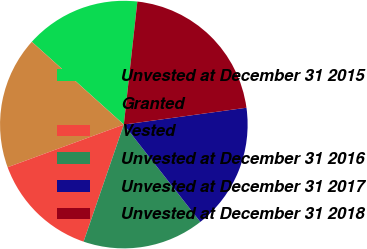<chart> <loc_0><loc_0><loc_500><loc_500><pie_chart><fcel>Unvested at December 31 2015<fcel>Granted<fcel>Vested<fcel>Unvested at December 31 2016<fcel>Unvested at December 31 2017<fcel>Unvested at December 31 2018<nl><fcel>15.08%<fcel>17.26%<fcel>14.13%<fcel>15.87%<fcel>16.57%<fcel>21.08%<nl></chart> 